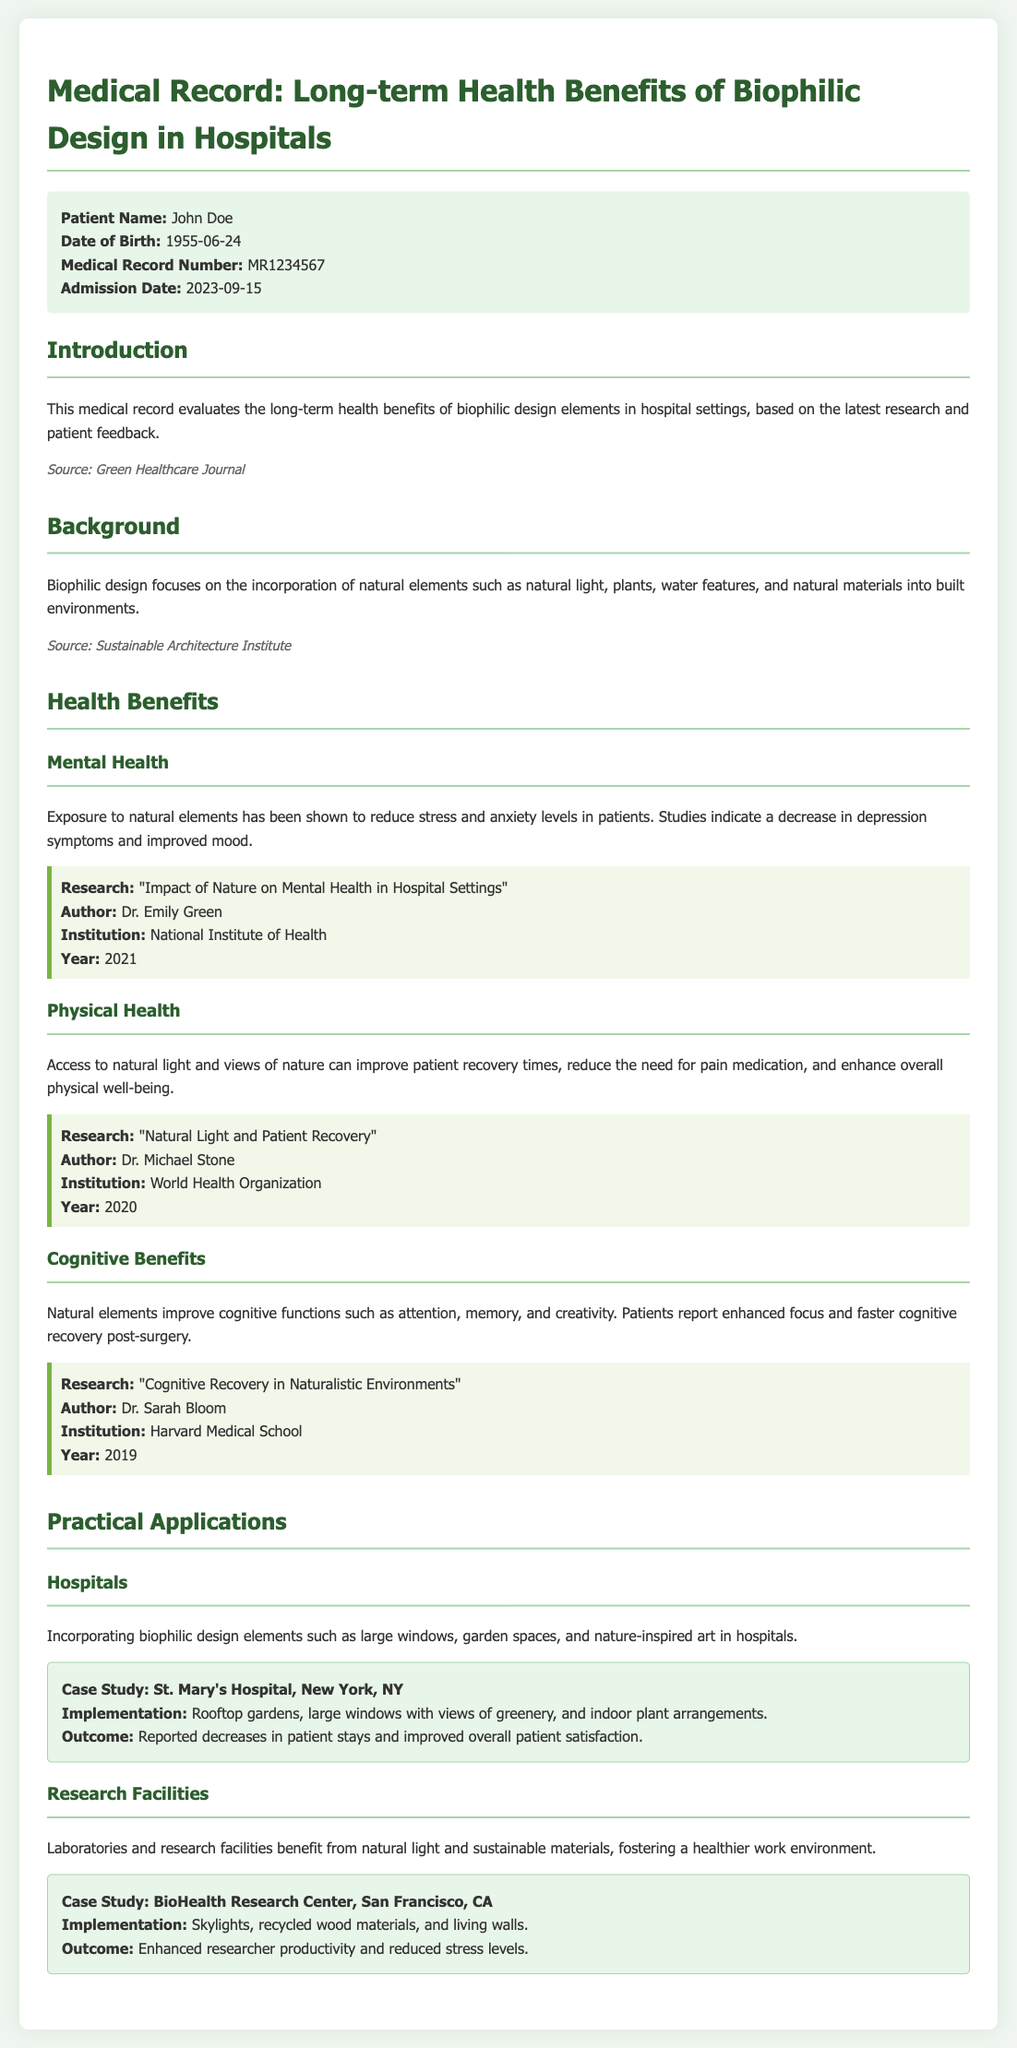What is the patient's name? The patient's name is mentioned in the patient information section of the document.
Answer: John Doe What is the admission date? The admission date is provided in the patient information section.
Answer: 2023-09-15 Who authored the research on mental health in hospital settings? The author information is included in the research box related to mental health.
Answer: Dr. Emily Green What are two design elements mentioned for hospitals? The document lists practical applications that highlight design elements for hospitals.
Answer: Large windows, garden spaces What year was the research on cognitive recovery conducted? The year for the cognitive recovery research is mentioned in the research box in the cognitive benefits section.
Answer: 2019 What was the outcome reported for St. Mary's Hospital? The outcome is specified in the case study section related to St. Mary's Hospital.
Answer: Reported decreases in patient stays and improved overall patient satisfaction Which institute published the research on natural light and patient recovery? The institution information is provided in the research box for physical health.
Answer: World Health Organization How do natural elements impact patient recovery times? The document explains the comprehensive effects of nature on patient recovery in the physical health section.
Answer: Improve recovery times What type of design does biophilic design focus on? The background section of the document outlines the focus of biophilic design.
Answer: Incorporation of natural elements 